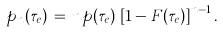<formula> <loc_0><loc_0><loc_500><loc_500>p _ { n } ( \tau _ { e } ) \, = \, n p ( \tau _ { e } ) \, \left [ 1 - F ( \tau _ { e } ) \right ] ^ { n - 1 } .</formula> 